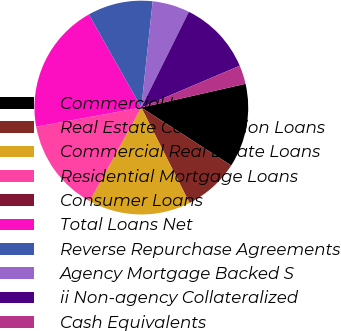Convert chart to OTSL. <chart><loc_0><loc_0><loc_500><loc_500><pie_chart><fcel>Commercial Loans<fcel>Real Estate Construction Loans<fcel>Commercial Real Estate Loans<fcel>Residential Mortgage Loans<fcel>Consumer Loans<fcel>Total Loans Net<fcel>Reverse Repurchase Agreements<fcel>Agency Mortgage Backed S<fcel>ii Non-agency Collateralized<fcel>Cash Equivalents<nl><fcel>12.67%<fcel>8.45%<fcel>15.48%<fcel>14.08%<fcel>0.02%<fcel>19.7%<fcel>9.86%<fcel>5.64%<fcel>11.27%<fcel>2.83%<nl></chart> 